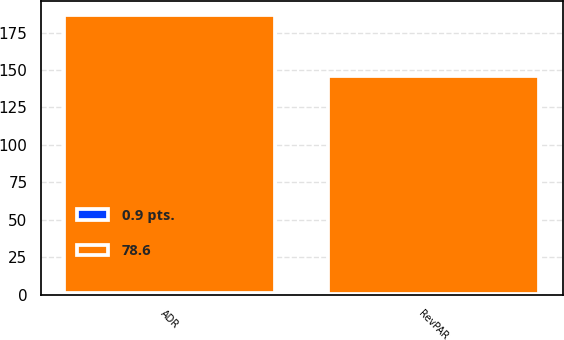<chart> <loc_0><loc_0><loc_500><loc_500><stacked_bar_chart><ecel><fcel>ADR<fcel>RevPAR<nl><fcel>78.6<fcel>185.18<fcel>145.49<nl><fcel>0.9 pts.<fcel>1.4<fcel>0.3<nl></chart> 